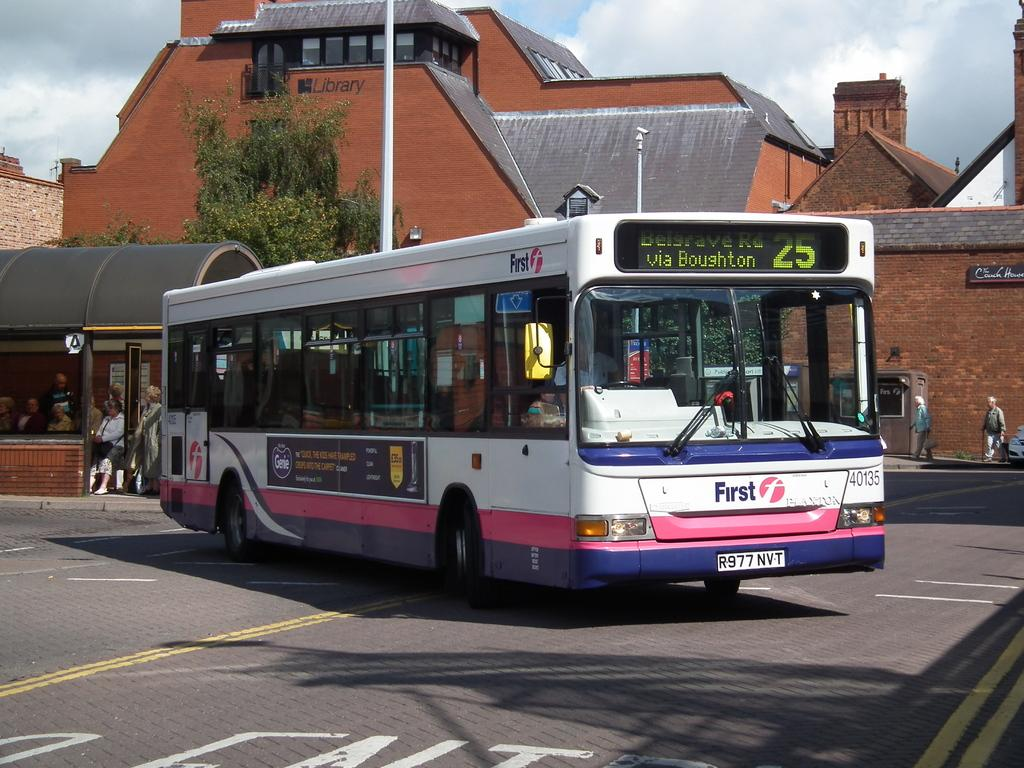<image>
Give a short and clear explanation of the subsequent image. a colorful public bus number 25 for Belgrave Rd 